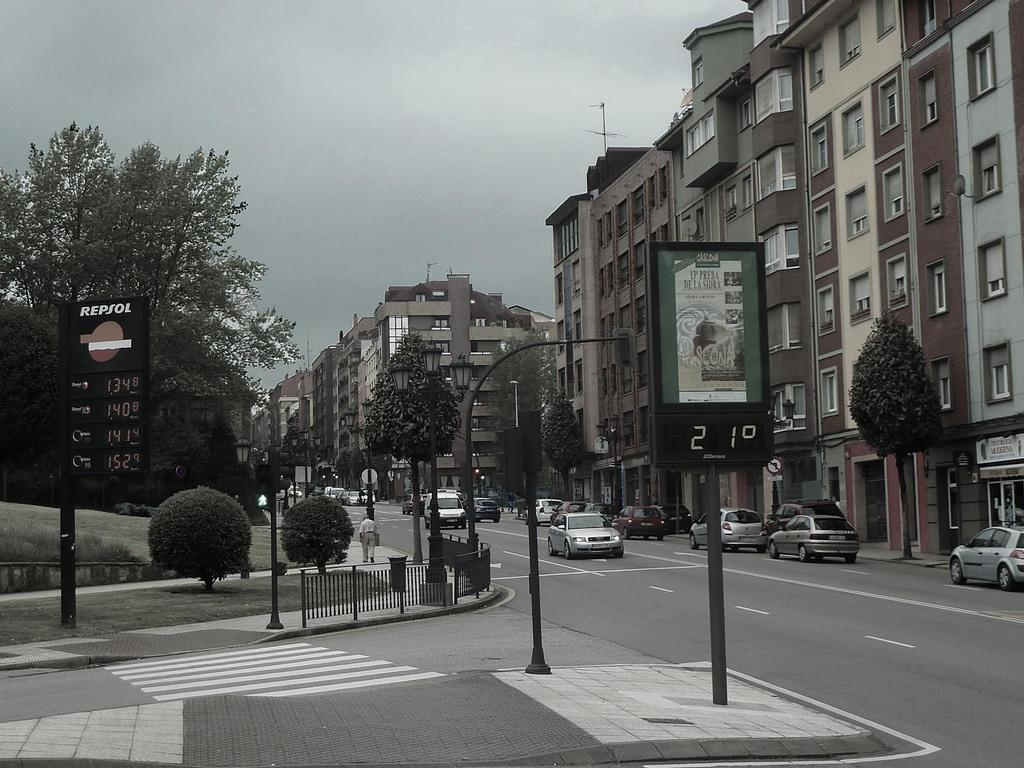<image>
Give a short and clear explanation of the subsequent image. A Repsol sign is on the left side of the street advertising prices. 